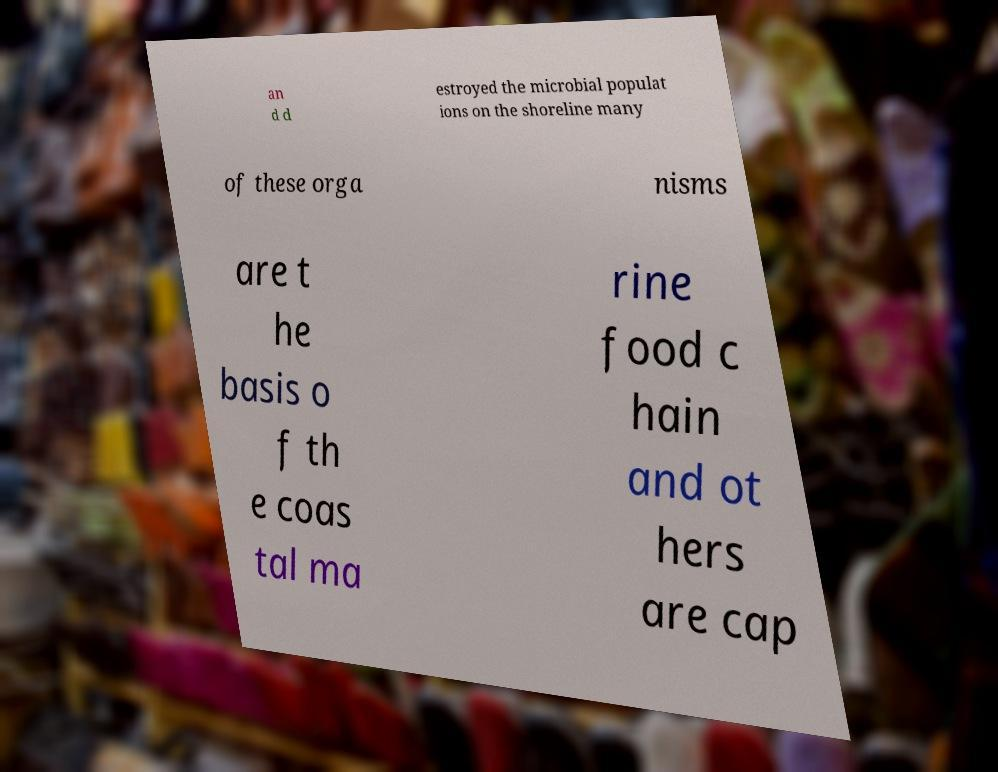What messages or text are displayed in this image? I need them in a readable, typed format. an d d estroyed the microbial populat ions on the shoreline many of these orga nisms are t he basis o f th e coas tal ma rine food c hain and ot hers are cap 